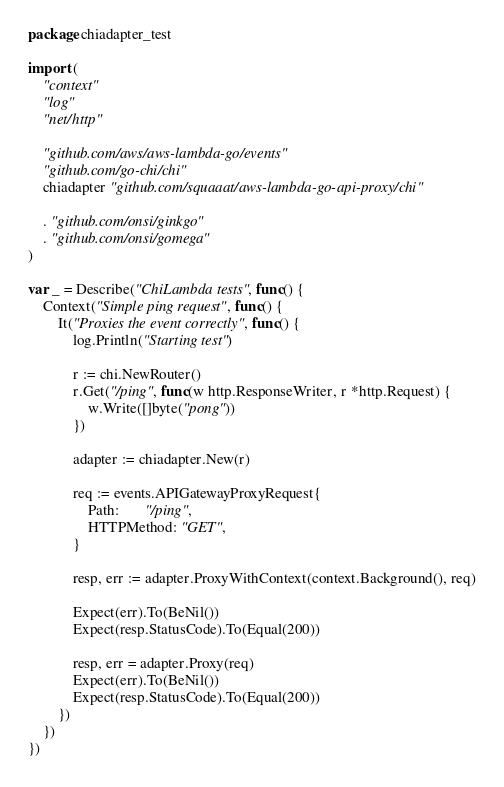<code> <loc_0><loc_0><loc_500><loc_500><_Go_>package chiadapter_test

import (
	"context"
	"log"
	"net/http"

	"github.com/aws/aws-lambda-go/events"
	"github.com/go-chi/chi"
	chiadapter "github.com/squaaat/aws-lambda-go-api-proxy/chi"

	. "github.com/onsi/ginkgo"
	. "github.com/onsi/gomega"
)

var _ = Describe("ChiLambda tests", func() {
	Context("Simple ping request", func() {
		It("Proxies the event correctly", func() {
			log.Println("Starting test")

			r := chi.NewRouter()
			r.Get("/ping", func(w http.ResponseWriter, r *http.Request) {
				w.Write([]byte("pong"))
			})

			adapter := chiadapter.New(r)

			req := events.APIGatewayProxyRequest{
				Path:       "/ping",
				HTTPMethod: "GET",
			}

			resp, err := adapter.ProxyWithContext(context.Background(), req)

			Expect(err).To(BeNil())
			Expect(resp.StatusCode).To(Equal(200))

			resp, err = adapter.Proxy(req)
			Expect(err).To(BeNil())
			Expect(resp.StatusCode).To(Equal(200))
		})
	})
})
</code> 